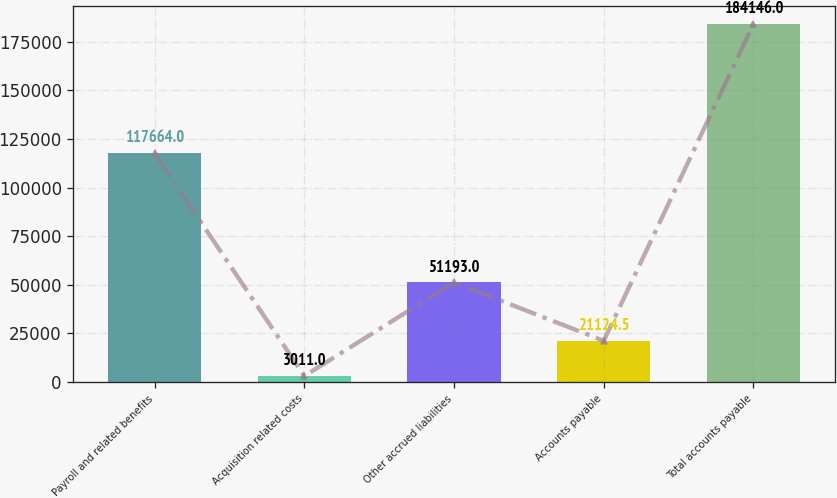Convert chart to OTSL. <chart><loc_0><loc_0><loc_500><loc_500><bar_chart><fcel>Payroll and related benefits<fcel>Acquisition related costs<fcel>Other accrued liabilities<fcel>Accounts payable<fcel>Total accounts payable<nl><fcel>117664<fcel>3011<fcel>51193<fcel>21124.5<fcel>184146<nl></chart> 